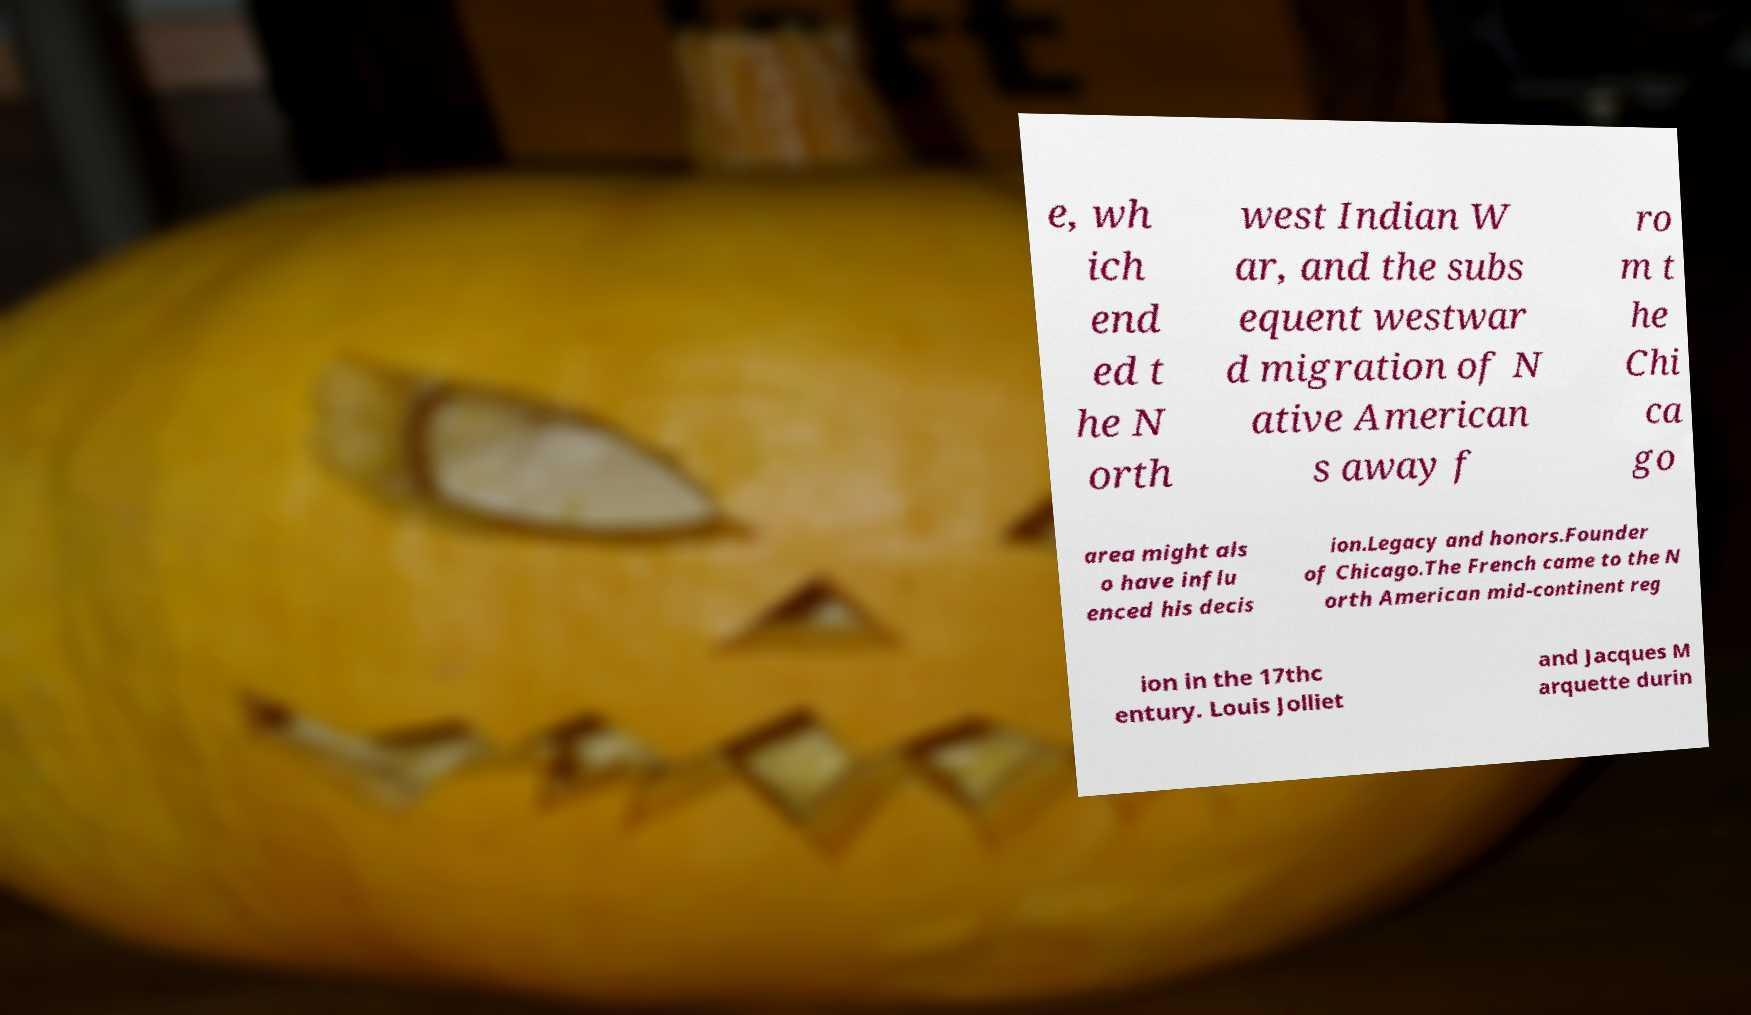Could you extract and type out the text from this image? e, wh ich end ed t he N orth west Indian W ar, and the subs equent westwar d migration of N ative American s away f ro m t he Chi ca go area might als o have influ enced his decis ion.Legacy and honors.Founder of Chicago.The French came to the N orth American mid-continent reg ion in the 17thc entury. Louis Jolliet and Jacques M arquette durin 